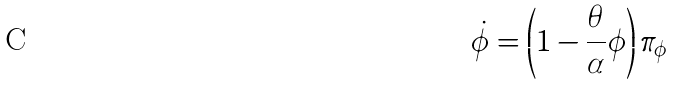Convert formula to latex. <formula><loc_0><loc_0><loc_500><loc_500>\dot { \phi } = \left ( 1 - \frac { \theta } { \alpha } \phi \right ) \pi _ { \phi }</formula> 